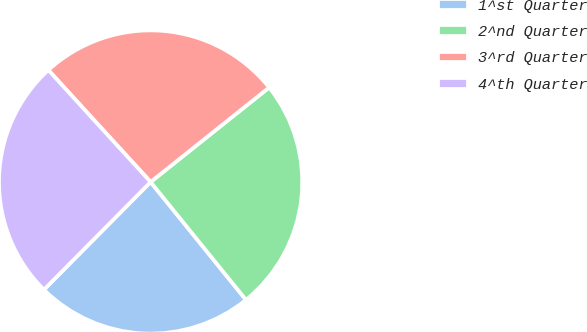Convert chart. <chart><loc_0><loc_0><loc_500><loc_500><pie_chart><fcel>1^st Quarter<fcel>2^nd Quarter<fcel>3^rd Quarter<fcel>4^th Quarter<nl><fcel>23.25%<fcel>24.89%<fcel>26.07%<fcel>25.79%<nl></chart> 